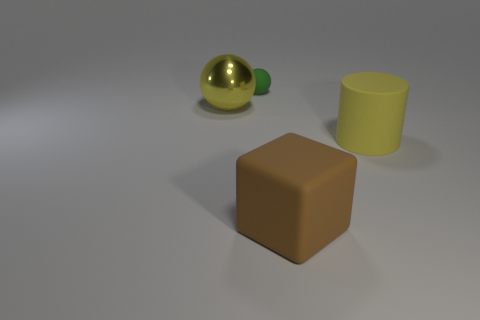Is there any other thing that has the same size as the green thing?
Keep it short and to the point. No. Is there any other thing that has the same shape as the yellow shiny object?
Your answer should be very brief. Yes. What is the material of the big yellow thing to the right of the large object to the left of the tiny green matte object?
Provide a short and direct response. Rubber. There is a yellow object on the right side of the tiny matte object; what size is it?
Your answer should be very brief. Large. The thing that is both on the right side of the big yellow sphere and left of the brown thing is what color?
Offer a terse response. Green. There is a yellow sphere that is to the left of the rubber block; does it have the same size as the brown matte cube?
Your answer should be very brief. Yes. There is a cube on the right side of the green object; is there a big matte cube behind it?
Your response must be concise. No. What is the yellow ball made of?
Provide a short and direct response. Metal. There is a yellow shiny thing; are there any big brown cubes on the left side of it?
Keep it short and to the point. No. There is a yellow shiny object that is the same shape as the green thing; what size is it?
Your answer should be very brief. Large. 